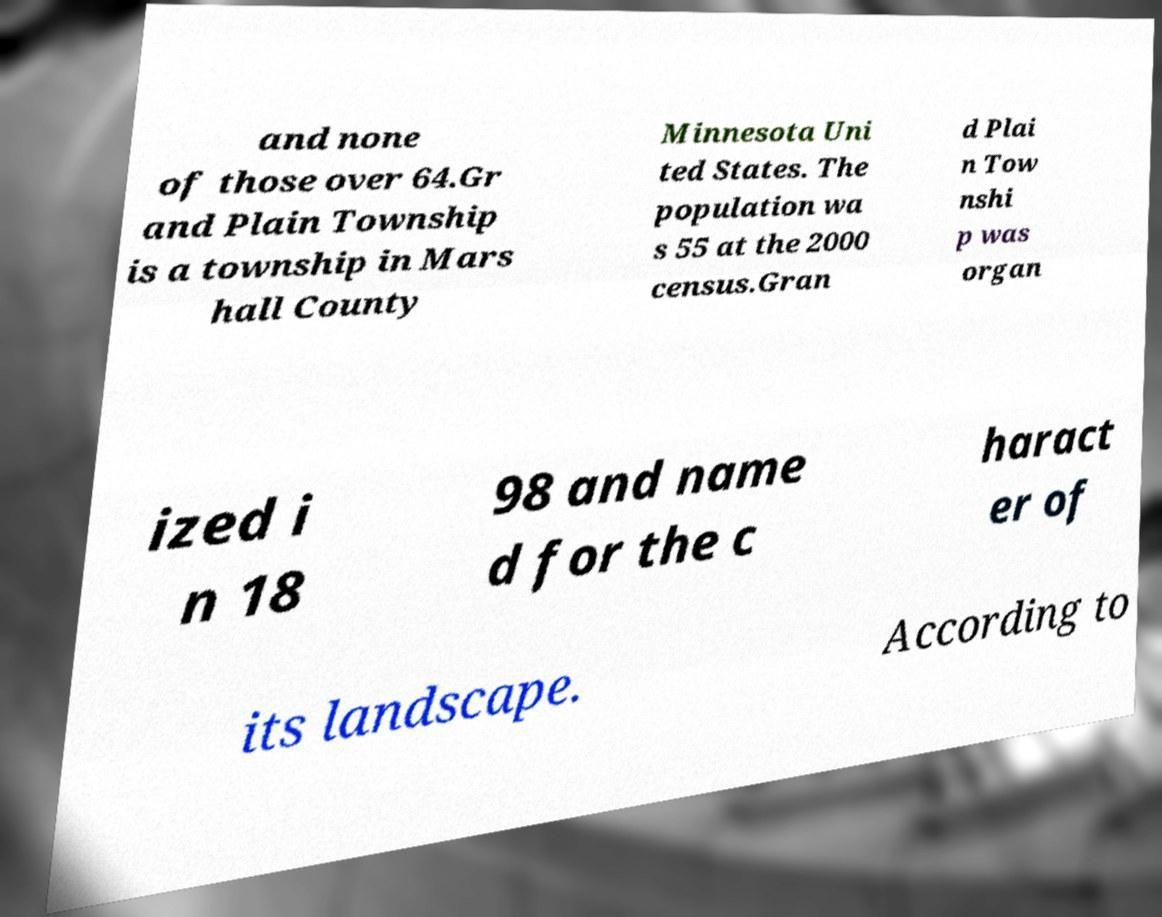There's text embedded in this image that I need extracted. Can you transcribe it verbatim? and none of those over 64.Gr and Plain Township is a township in Mars hall County Minnesota Uni ted States. The population wa s 55 at the 2000 census.Gran d Plai n Tow nshi p was organ ized i n 18 98 and name d for the c haract er of its landscape. According to 